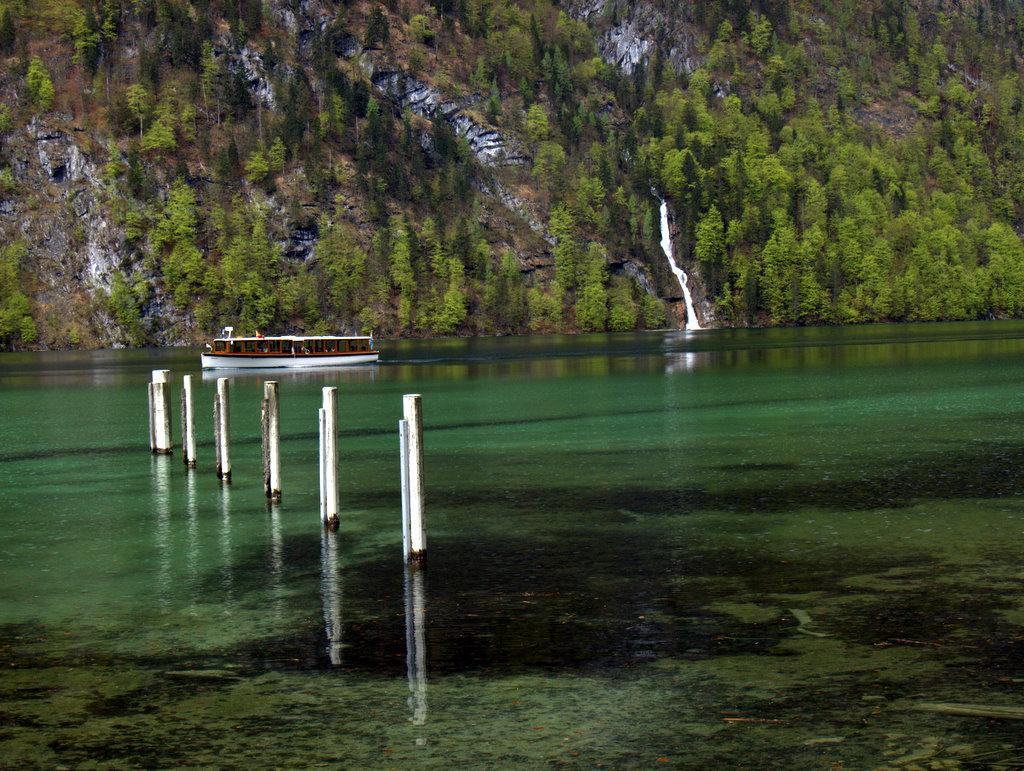What is the primary element in the image? There is water in the image. What is moving within the water? A boat is traveling in the water. What type of vegetation can be seen in the image? There are big trees in the image. What color is the sweater worn by the guide in the image? There is no guide or sweater present in the image. How many bubbles can be seen around the boat in the image? There are no bubbles visible in the image; it only shows a boat traveling in the water. 